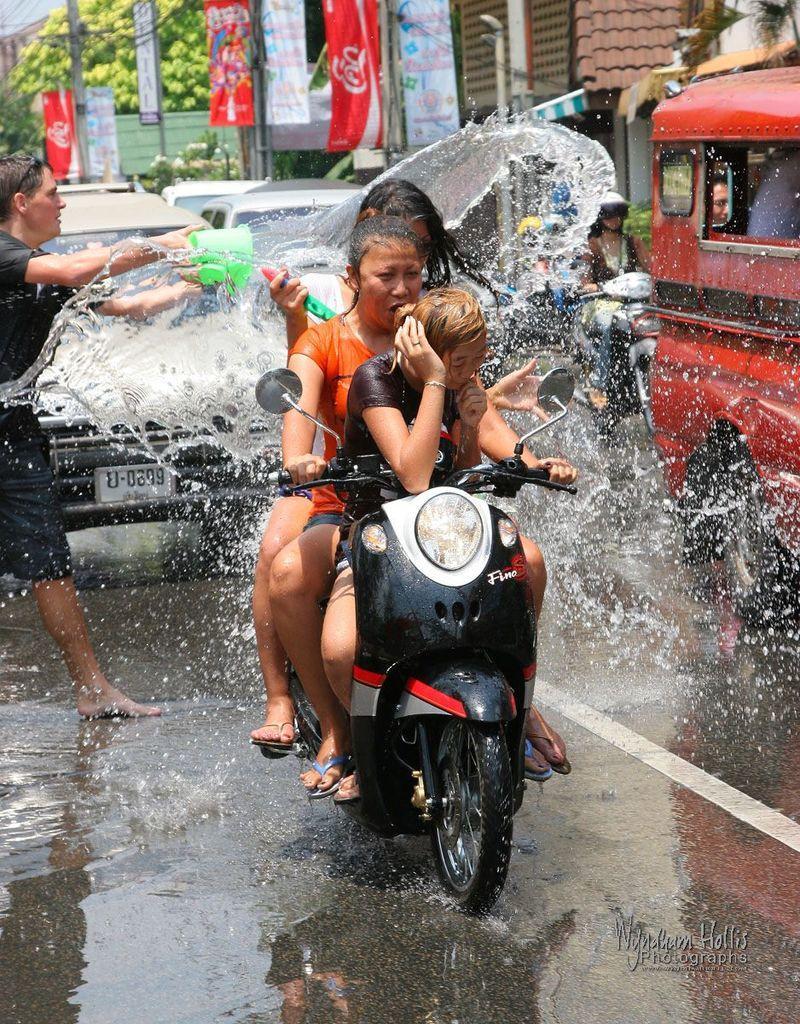In one or two sentences, can you explain what this image depicts? In the center of the image there are three women on the scooter. Behind the scooter there are cars and beside to it is a bus. On the left corner of the image there is a man pouring water on the bus with the bucket. The second woman on the scooter is driving the scooter. In the background there are flags, hoardings, trees and building. There is also a pole. The woman behind the bus driving the scooter is wearing a helmet.  